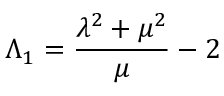Convert formula to latex. <formula><loc_0><loc_0><loc_500><loc_500>\Lambda _ { 1 } = \frac { \lambda ^ { 2 } + \mu ^ { 2 } } { \mu } - 2</formula> 